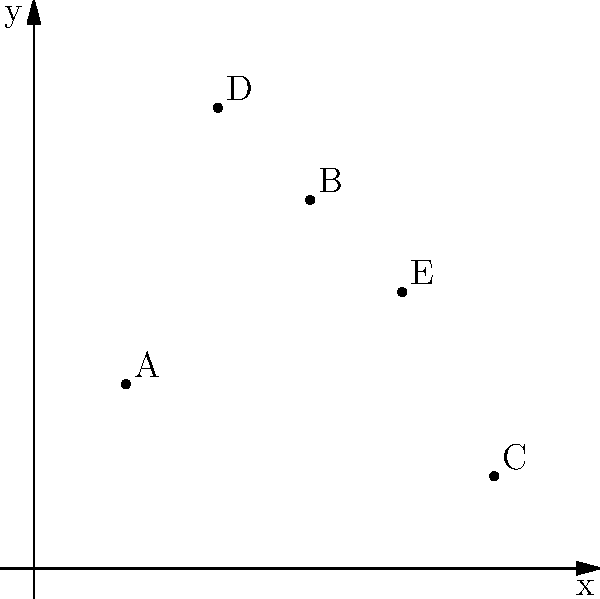Given the locations of five power plants (A, B, C, D, and E) on a coordinate grid, which plant is best positioned to serve as the central distribution hub to minimize the total distance to all other plants? Assume Manhattan distance (L1 norm) for calculations. To find the optimal central distribution hub, we need to calculate the total Manhattan distance from each plant to all others and choose the one with the minimum total distance. The Manhattan distance between two points $(x_1, y_1)$ and $(x_2, y_2)$ is given by $|x_1 - x_2| + |y_1 - y_2|$.

Step 1: List the coordinates of each plant:
A (1, 2), B (3, 4), C (5, 1), D (2, 5), E (4, 3)

Step 2: Calculate the total Manhattan distance for each plant to all others:

For A:
To B: |1-3| + |2-4| = 4
To C: |1-5| + |2-1| = 5
To D: |1-2| + |2-5| = 4
To E: |1-4| + |2-3| = 4
Total: 17

For B:
To A: |3-1| + |4-2| = 4
To C: |3-5| + |4-1| = 5
To D: |3-2| + |4-5| = 2
To E: |3-4| + |4-3| = 2
Total: 13

For C:
To A: |5-1| + |1-2| = 5
To B: |5-3| + |1-4| = 5
To D: |5-2| + |1-5| = 7
To E: |5-4| + |1-3| = 3
Total: 20

For D:
To A: |2-1| + |5-2| = 4
To B: |2-3| + |5-4| = 2
To C: |2-5| + |5-1| = 7
To E: |2-4| + |5-3| = 4
Total: 17

For E:
To A: |4-1| + |3-2| = 4
To B: |4-3| + |3-4| = 2
To C: |4-5| + |3-1| = 3
To D: |4-2| + |3-5| = 4
Total: 13

Step 3: Identify the plant with the minimum total distance.

Plants B and E both have the minimum total distance of 13.
Answer: B or E 